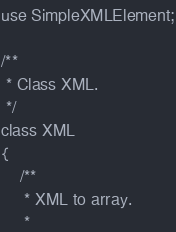Convert code to text. <code><loc_0><loc_0><loc_500><loc_500><_PHP_>
use SimpleXMLElement;

/**
 * Class XML.
 */
class XML
{
    /**
     * XML to array.
     *</code> 